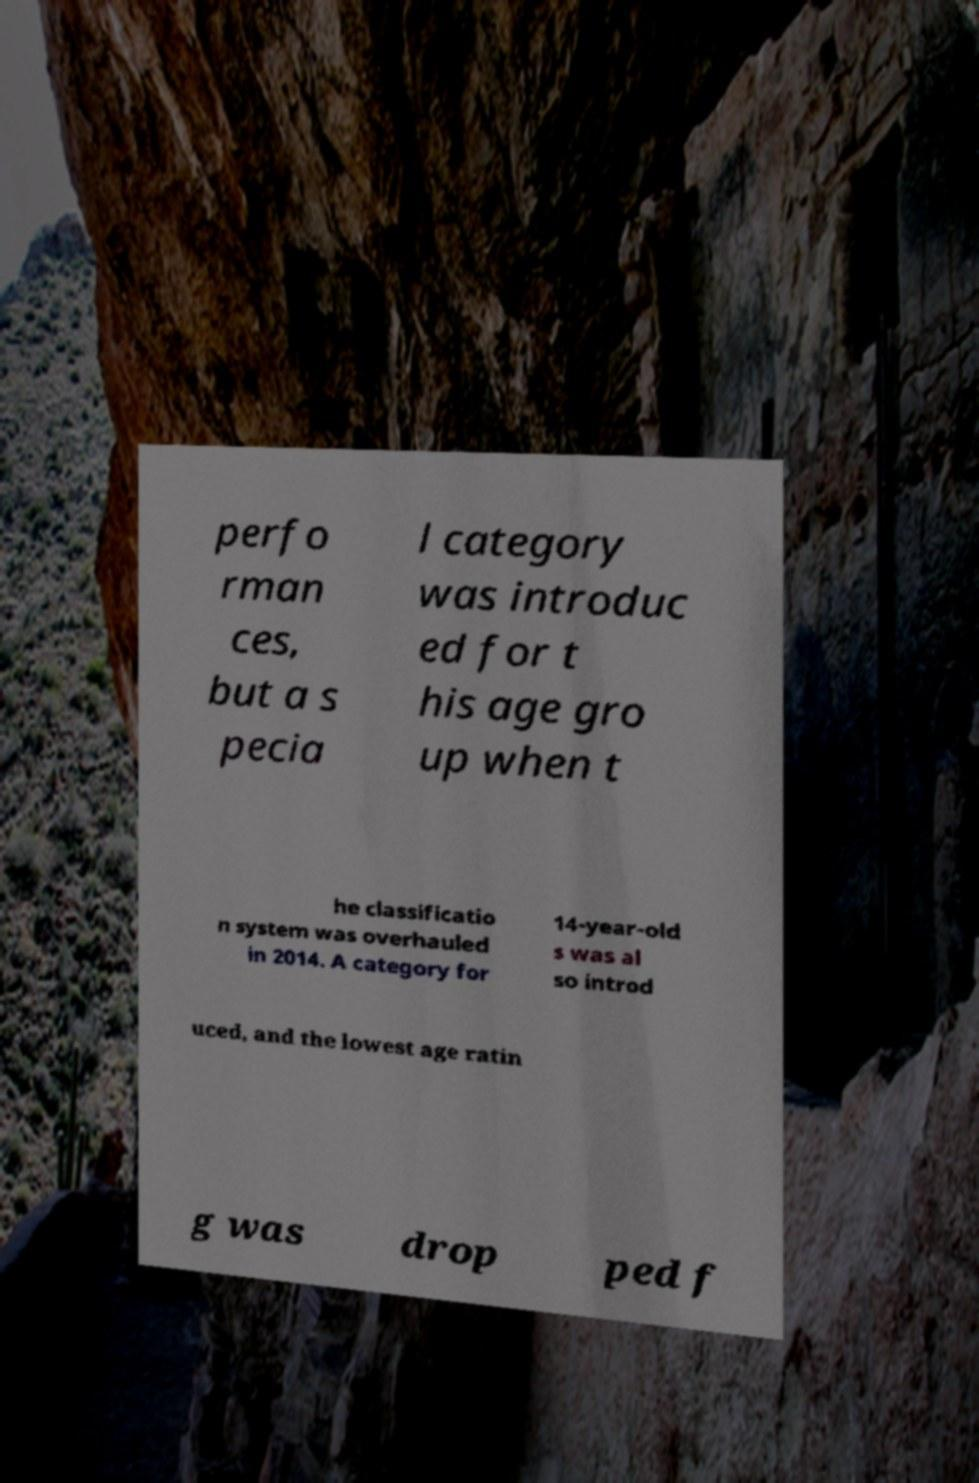Could you assist in decoding the text presented in this image and type it out clearly? perfo rman ces, but a s pecia l category was introduc ed for t his age gro up when t he classificatio n system was overhauled in 2014. A category for 14-year-old s was al so introd uced, and the lowest age ratin g was drop ped f 